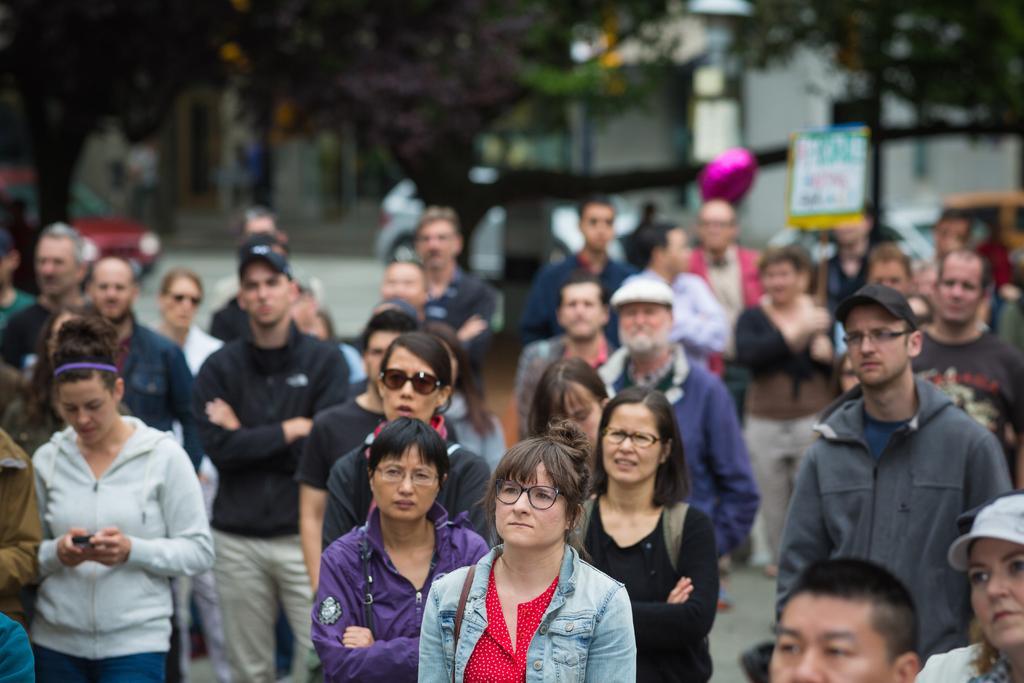Describe this image in one or two sentences. In this image I can see group of people standing on the road, they are wearing multi color dresses. Background I can see few vehicles on the road and trees and I can also see few buildings. 